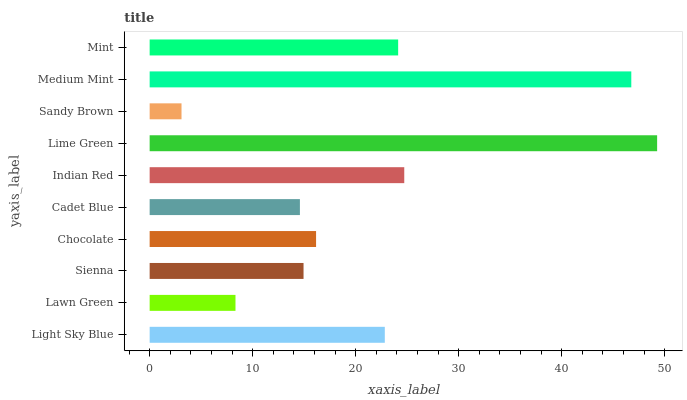Is Sandy Brown the minimum?
Answer yes or no. Yes. Is Lime Green the maximum?
Answer yes or no. Yes. Is Lawn Green the minimum?
Answer yes or no. No. Is Lawn Green the maximum?
Answer yes or no. No. Is Light Sky Blue greater than Lawn Green?
Answer yes or no. Yes. Is Lawn Green less than Light Sky Blue?
Answer yes or no. Yes. Is Lawn Green greater than Light Sky Blue?
Answer yes or no. No. Is Light Sky Blue less than Lawn Green?
Answer yes or no. No. Is Light Sky Blue the high median?
Answer yes or no. Yes. Is Chocolate the low median?
Answer yes or no. Yes. Is Sienna the high median?
Answer yes or no. No. Is Light Sky Blue the low median?
Answer yes or no. No. 